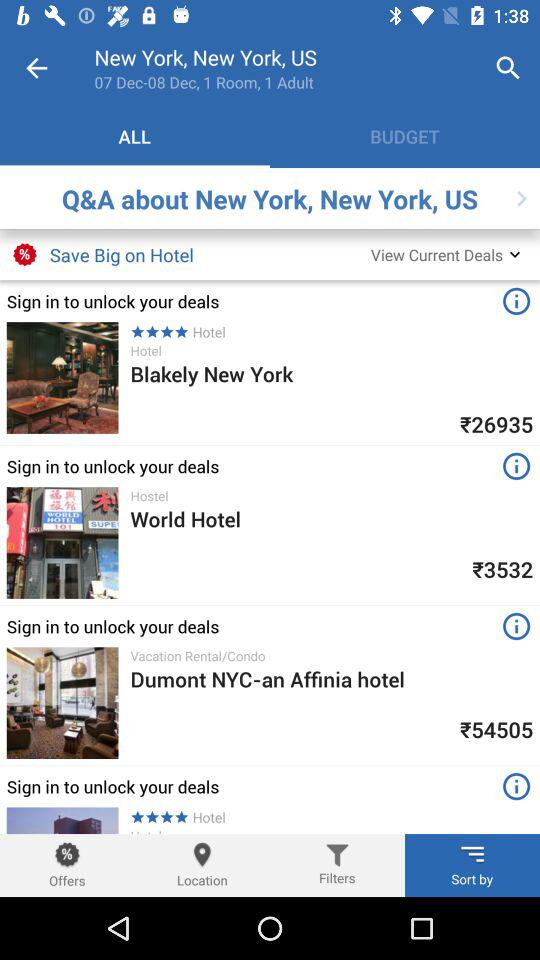What's the price of the World Hotel? The price of the World Hotel is ₹3532. 